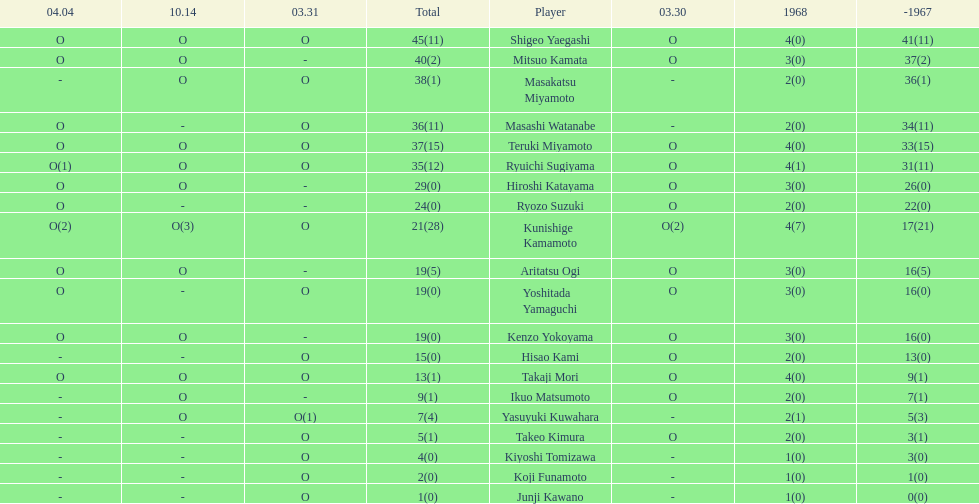Can you parse all the data within this table? {'header': ['04.04', '10.14', '03.31', 'Total', 'Player', '03.30', '1968', '-1967'], 'rows': [['O', 'O', 'O', '45(11)', 'Shigeo Yaegashi', 'O', '4(0)', '41(11)'], ['O', 'O', '-', '40(2)', 'Mitsuo Kamata', 'O', '3(0)', '37(2)'], ['-', 'O', 'O', '38(1)', 'Masakatsu Miyamoto', '-', '2(0)', '36(1)'], ['O', '-', 'O', '36(11)', 'Masashi Watanabe', '-', '2(0)', '34(11)'], ['O', 'O', 'O', '37(15)', 'Teruki Miyamoto', 'O', '4(0)', '33(15)'], ['O(1)', 'O', 'O', '35(12)', 'Ryuichi Sugiyama', 'O', '4(1)', '31(11)'], ['O', 'O', '-', '29(0)', 'Hiroshi Katayama', 'O', '3(0)', '26(0)'], ['O', '-', '-', '24(0)', 'Ryozo Suzuki', 'O', '2(0)', '22(0)'], ['O(2)', 'O(3)', 'O', '21(28)', 'Kunishige Kamamoto', 'O(2)', '4(7)', '17(21)'], ['O', 'O', '-', '19(5)', 'Aritatsu Ogi', 'O', '3(0)', '16(5)'], ['O', '-', 'O', '19(0)', 'Yoshitada Yamaguchi', 'O', '3(0)', '16(0)'], ['O', 'O', '-', '19(0)', 'Kenzo Yokoyama', 'O', '3(0)', '16(0)'], ['-', '-', 'O', '15(0)', 'Hisao Kami', 'O', '2(0)', '13(0)'], ['O', 'O', 'O', '13(1)', 'Takaji Mori', 'O', '4(0)', '9(1)'], ['-', 'O', '-', '9(1)', 'Ikuo Matsumoto', 'O', '2(0)', '7(1)'], ['-', 'O', 'O(1)', '7(4)', 'Yasuyuki Kuwahara', '-', '2(1)', '5(3)'], ['-', '-', 'O', '5(1)', 'Takeo Kimura', 'O', '2(0)', '3(1)'], ['-', '-', 'O', '4(0)', 'Kiyoshi Tomizawa', '-', '1(0)', '3(0)'], ['-', '-', 'O', '2(0)', 'Koji Funamoto', '-', '1(0)', '1(0)'], ['-', '-', 'O', '1(0)', 'Junji Kawano', '-', '1(0)', '0(0)']]} Who had more points takaji mori or junji kawano? Takaji Mori. 